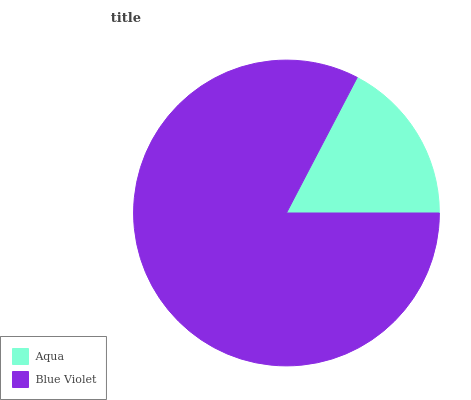Is Aqua the minimum?
Answer yes or no. Yes. Is Blue Violet the maximum?
Answer yes or no. Yes. Is Blue Violet the minimum?
Answer yes or no. No. Is Blue Violet greater than Aqua?
Answer yes or no. Yes. Is Aqua less than Blue Violet?
Answer yes or no. Yes. Is Aqua greater than Blue Violet?
Answer yes or no. No. Is Blue Violet less than Aqua?
Answer yes or no. No. Is Blue Violet the high median?
Answer yes or no. Yes. Is Aqua the low median?
Answer yes or no. Yes. Is Aqua the high median?
Answer yes or no. No. Is Blue Violet the low median?
Answer yes or no. No. 